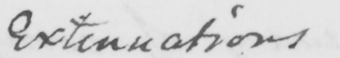Transcribe the text shown in this historical manuscript line. Extenuations 